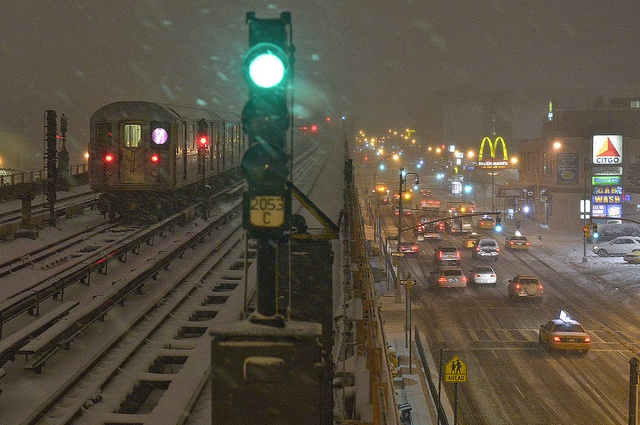Describe the objects in this image and their specific colors. I can see train in gray, black, and maroon tones, traffic light in gray, black, teal, white, and darkgreen tones, car in gray, maroon, and brown tones, car in gray, black, and maroon tones, and car in gray, maroon, and black tones in this image. 